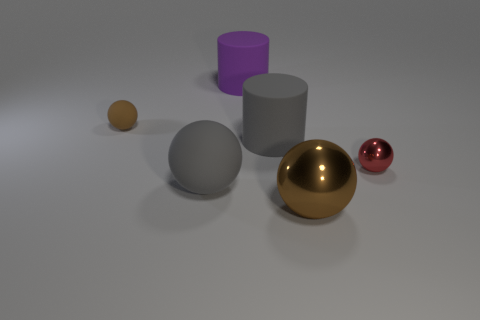Is there any other thing of the same color as the tiny shiny object?
Your response must be concise. No. The big gray thing that is the same material as the gray ball is what shape?
Keep it short and to the point. Cylinder. How many objects are behind the brown object to the left of the big gray rubber sphere in front of the brown rubber object?
Provide a short and direct response. 1. What shape is the matte thing that is both left of the large purple rubber thing and to the right of the tiny brown matte object?
Provide a succinct answer. Sphere. Is the number of big gray spheres that are in front of the big brown sphere less than the number of tiny purple metallic things?
Provide a short and direct response. No. How many small things are purple things or shiny balls?
Provide a succinct answer. 1. The gray cylinder is what size?
Your response must be concise. Large. There is a small red sphere; what number of metallic objects are to the left of it?
Keep it short and to the point. 1. There is a gray object that is the same shape as the brown matte thing; what is its size?
Keep it short and to the point. Large. There is a rubber object that is both on the right side of the large gray ball and in front of the large purple matte cylinder; what size is it?
Ensure brevity in your answer.  Large. 